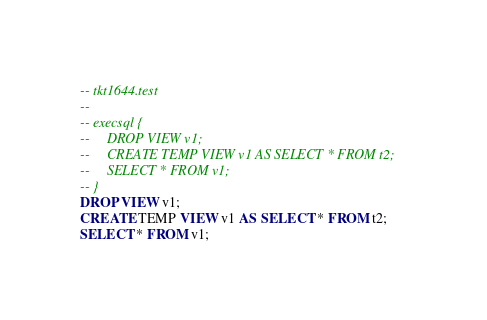Convert code to text. <code><loc_0><loc_0><loc_500><loc_500><_SQL_>-- tkt1644.test
-- 
-- execsql {
--     DROP VIEW v1;
--     CREATE TEMP VIEW v1 AS SELECT * FROM t2;
--     SELECT * FROM v1;
-- }
DROP VIEW v1;
CREATE TEMP VIEW v1 AS SELECT * FROM t2;
SELECT * FROM v1;</code> 